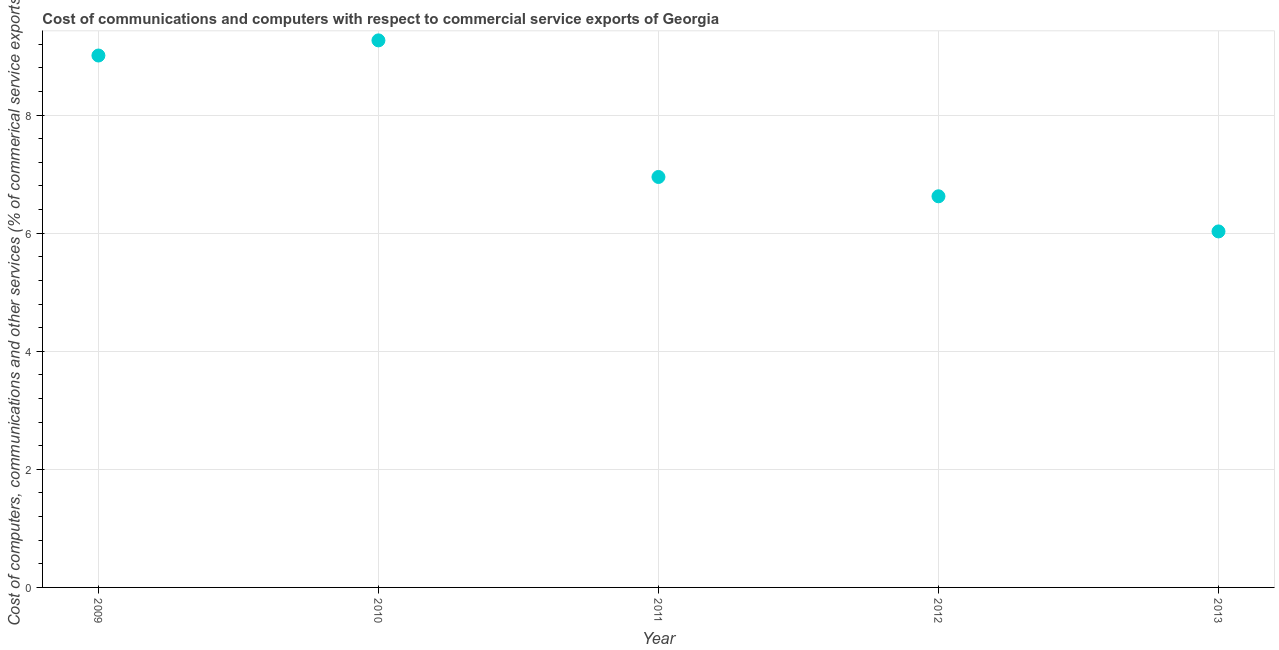What is the  computer and other services in 2012?
Provide a succinct answer. 6.62. Across all years, what is the maximum  computer and other services?
Provide a short and direct response. 9.27. Across all years, what is the minimum cost of communications?
Provide a short and direct response. 6.03. In which year was the  computer and other services maximum?
Provide a succinct answer. 2010. In which year was the  computer and other services minimum?
Provide a succinct answer. 2013. What is the sum of the  computer and other services?
Your response must be concise. 37.88. What is the difference between the  computer and other services in 2011 and 2012?
Offer a very short reply. 0.33. What is the average cost of communications per year?
Give a very brief answer. 7.58. What is the median cost of communications?
Give a very brief answer. 6.95. What is the ratio of the cost of communications in 2009 to that in 2013?
Provide a succinct answer. 1.49. What is the difference between the highest and the second highest cost of communications?
Offer a very short reply. 0.26. What is the difference between the highest and the lowest  computer and other services?
Your response must be concise. 3.24. In how many years, is the cost of communications greater than the average cost of communications taken over all years?
Ensure brevity in your answer.  2. How many dotlines are there?
Offer a very short reply. 1. How many years are there in the graph?
Your response must be concise. 5. What is the difference between two consecutive major ticks on the Y-axis?
Provide a succinct answer. 2. Are the values on the major ticks of Y-axis written in scientific E-notation?
Ensure brevity in your answer.  No. Does the graph contain grids?
Keep it short and to the point. Yes. What is the title of the graph?
Keep it short and to the point. Cost of communications and computers with respect to commercial service exports of Georgia. What is the label or title of the X-axis?
Keep it short and to the point. Year. What is the label or title of the Y-axis?
Offer a very short reply. Cost of computers, communications and other services (% of commerical service exports). What is the Cost of computers, communications and other services (% of commerical service exports) in 2009?
Your answer should be compact. 9.01. What is the Cost of computers, communications and other services (% of commerical service exports) in 2010?
Give a very brief answer. 9.27. What is the Cost of computers, communications and other services (% of commerical service exports) in 2011?
Give a very brief answer. 6.95. What is the Cost of computers, communications and other services (% of commerical service exports) in 2012?
Keep it short and to the point. 6.62. What is the Cost of computers, communications and other services (% of commerical service exports) in 2013?
Your answer should be very brief. 6.03. What is the difference between the Cost of computers, communications and other services (% of commerical service exports) in 2009 and 2010?
Offer a very short reply. -0.26. What is the difference between the Cost of computers, communications and other services (% of commerical service exports) in 2009 and 2011?
Your answer should be compact. 2.06. What is the difference between the Cost of computers, communications and other services (% of commerical service exports) in 2009 and 2012?
Provide a succinct answer. 2.38. What is the difference between the Cost of computers, communications and other services (% of commerical service exports) in 2009 and 2013?
Offer a terse response. 2.98. What is the difference between the Cost of computers, communications and other services (% of commerical service exports) in 2010 and 2011?
Provide a short and direct response. 2.31. What is the difference between the Cost of computers, communications and other services (% of commerical service exports) in 2010 and 2012?
Provide a short and direct response. 2.64. What is the difference between the Cost of computers, communications and other services (% of commerical service exports) in 2010 and 2013?
Offer a very short reply. 3.24. What is the difference between the Cost of computers, communications and other services (% of commerical service exports) in 2011 and 2012?
Ensure brevity in your answer.  0.33. What is the difference between the Cost of computers, communications and other services (% of commerical service exports) in 2011 and 2013?
Offer a very short reply. 0.92. What is the difference between the Cost of computers, communications and other services (% of commerical service exports) in 2012 and 2013?
Keep it short and to the point. 0.6. What is the ratio of the Cost of computers, communications and other services (% of commerical service exports) in 2009 to that in 2010?
Your answer should be very brief. 0.97. What is the ratio of the Cost of computers, communications and other services (% of commerical service exports) in 2009 to that in 2011?
Give a very brief answer. 1.3. What is the ratio of the Cost of computers, communications and other services (% of commerical service exports) in 2009 to that in 2012?
Your response must be concise. 1.36. What is the ratio of the Cost of computers, communications and other services (% of commerical service exports) in 2009 to that in 2013?
Give a very brief answer. 1.49. What is the ratio of the Cost of computers, communications and other services (% of commerical service exports) in 2010 to that in 2011?
Ensure brevity in your answer.  1.33. What is the ratio of the Cost of computers, communications and other services (% of commerical service exports) in 2010 to that in 2012?
Provide a short and direct response. 1.4. What is the ratio of the Cost of computers, communications and other services (% of commerical service exports) in 2010 to that in 2013?
Your answer should be very brief. 1.54. What is the ratio of the Cost of computers, communications and other services (% of commerical service exports) in 2011 to that in 2012?
Offer a very short reply. 1.05. What is the ratio of the Cost of computers, communications and other services (% of commerical service exports) in 2011 to that in 2013?
Make the answer very short. 1.15. What is the ratio of the Cost of computers, communications and other services (% of commerical service exports) in 2012 to that in 2013?
Your response must be concise. 1.1. 